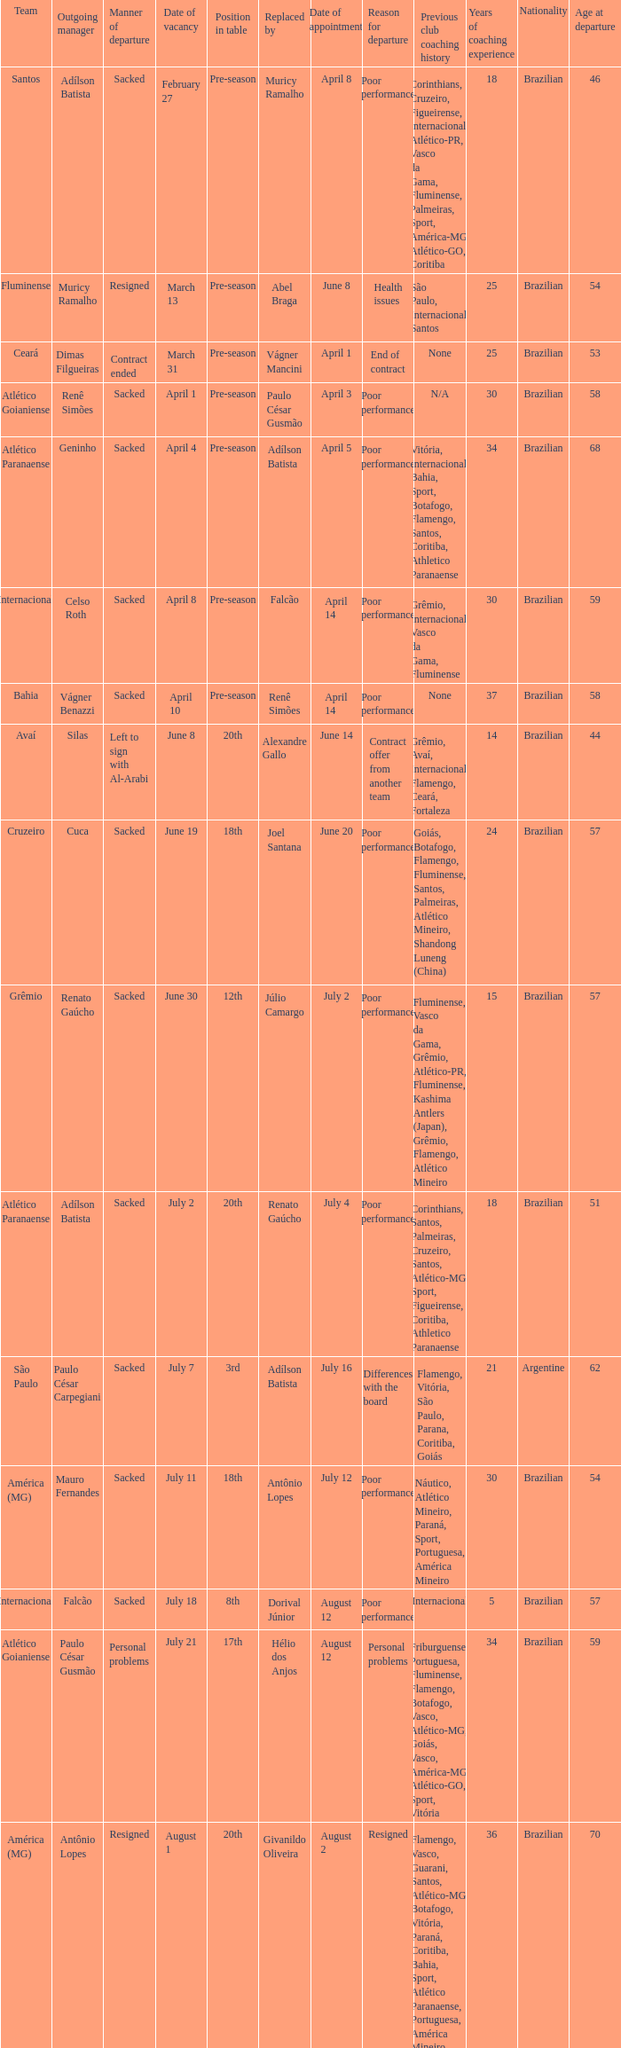How many times did Silas leave as a team manager? 1.0. 